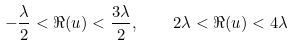Convert formula to latex. <formula><loc_0><loc_0><loc_500><loc_500>- \frac { \lambda } { 2 } < \Re ( u ) < \frac { 3 \lambda } { 2 } , \quad 2 \lambda < \Re ( u ) < 4 \lambda</formula> 